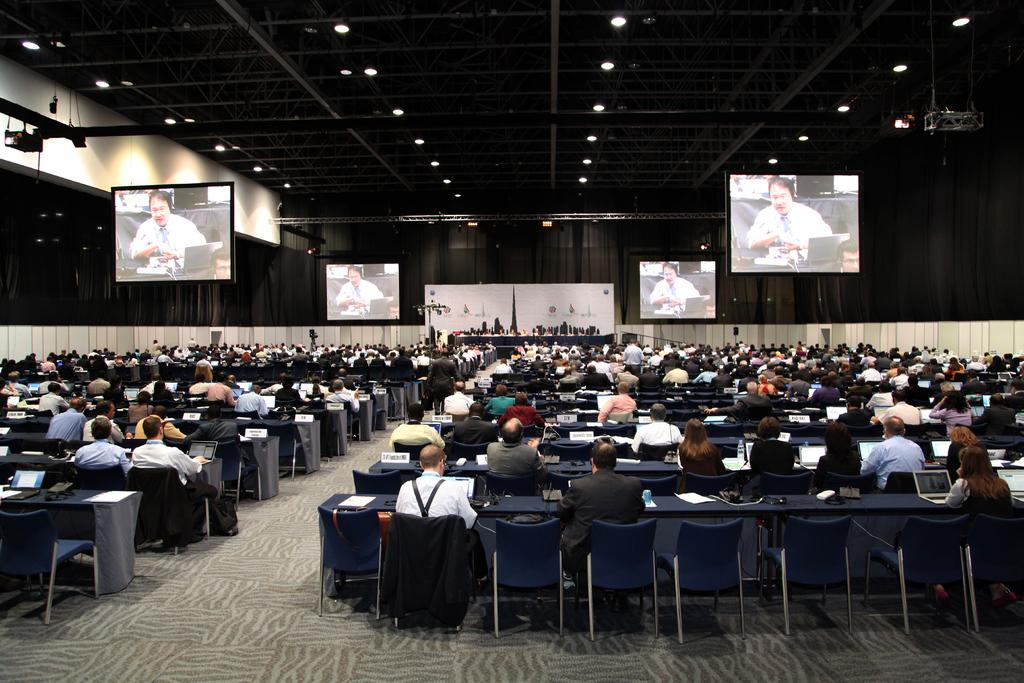What are the people in the image doing? The people in the image are sitting in chairs. What is in front of the people? There is a table in front of the people. What can be seen on the table? There are four projected images in front of the people. What type of bird can be seen flying through the window in the image? There is no bird or window present in the image; it only features people sitting in chairs, a table, and four projected images. 